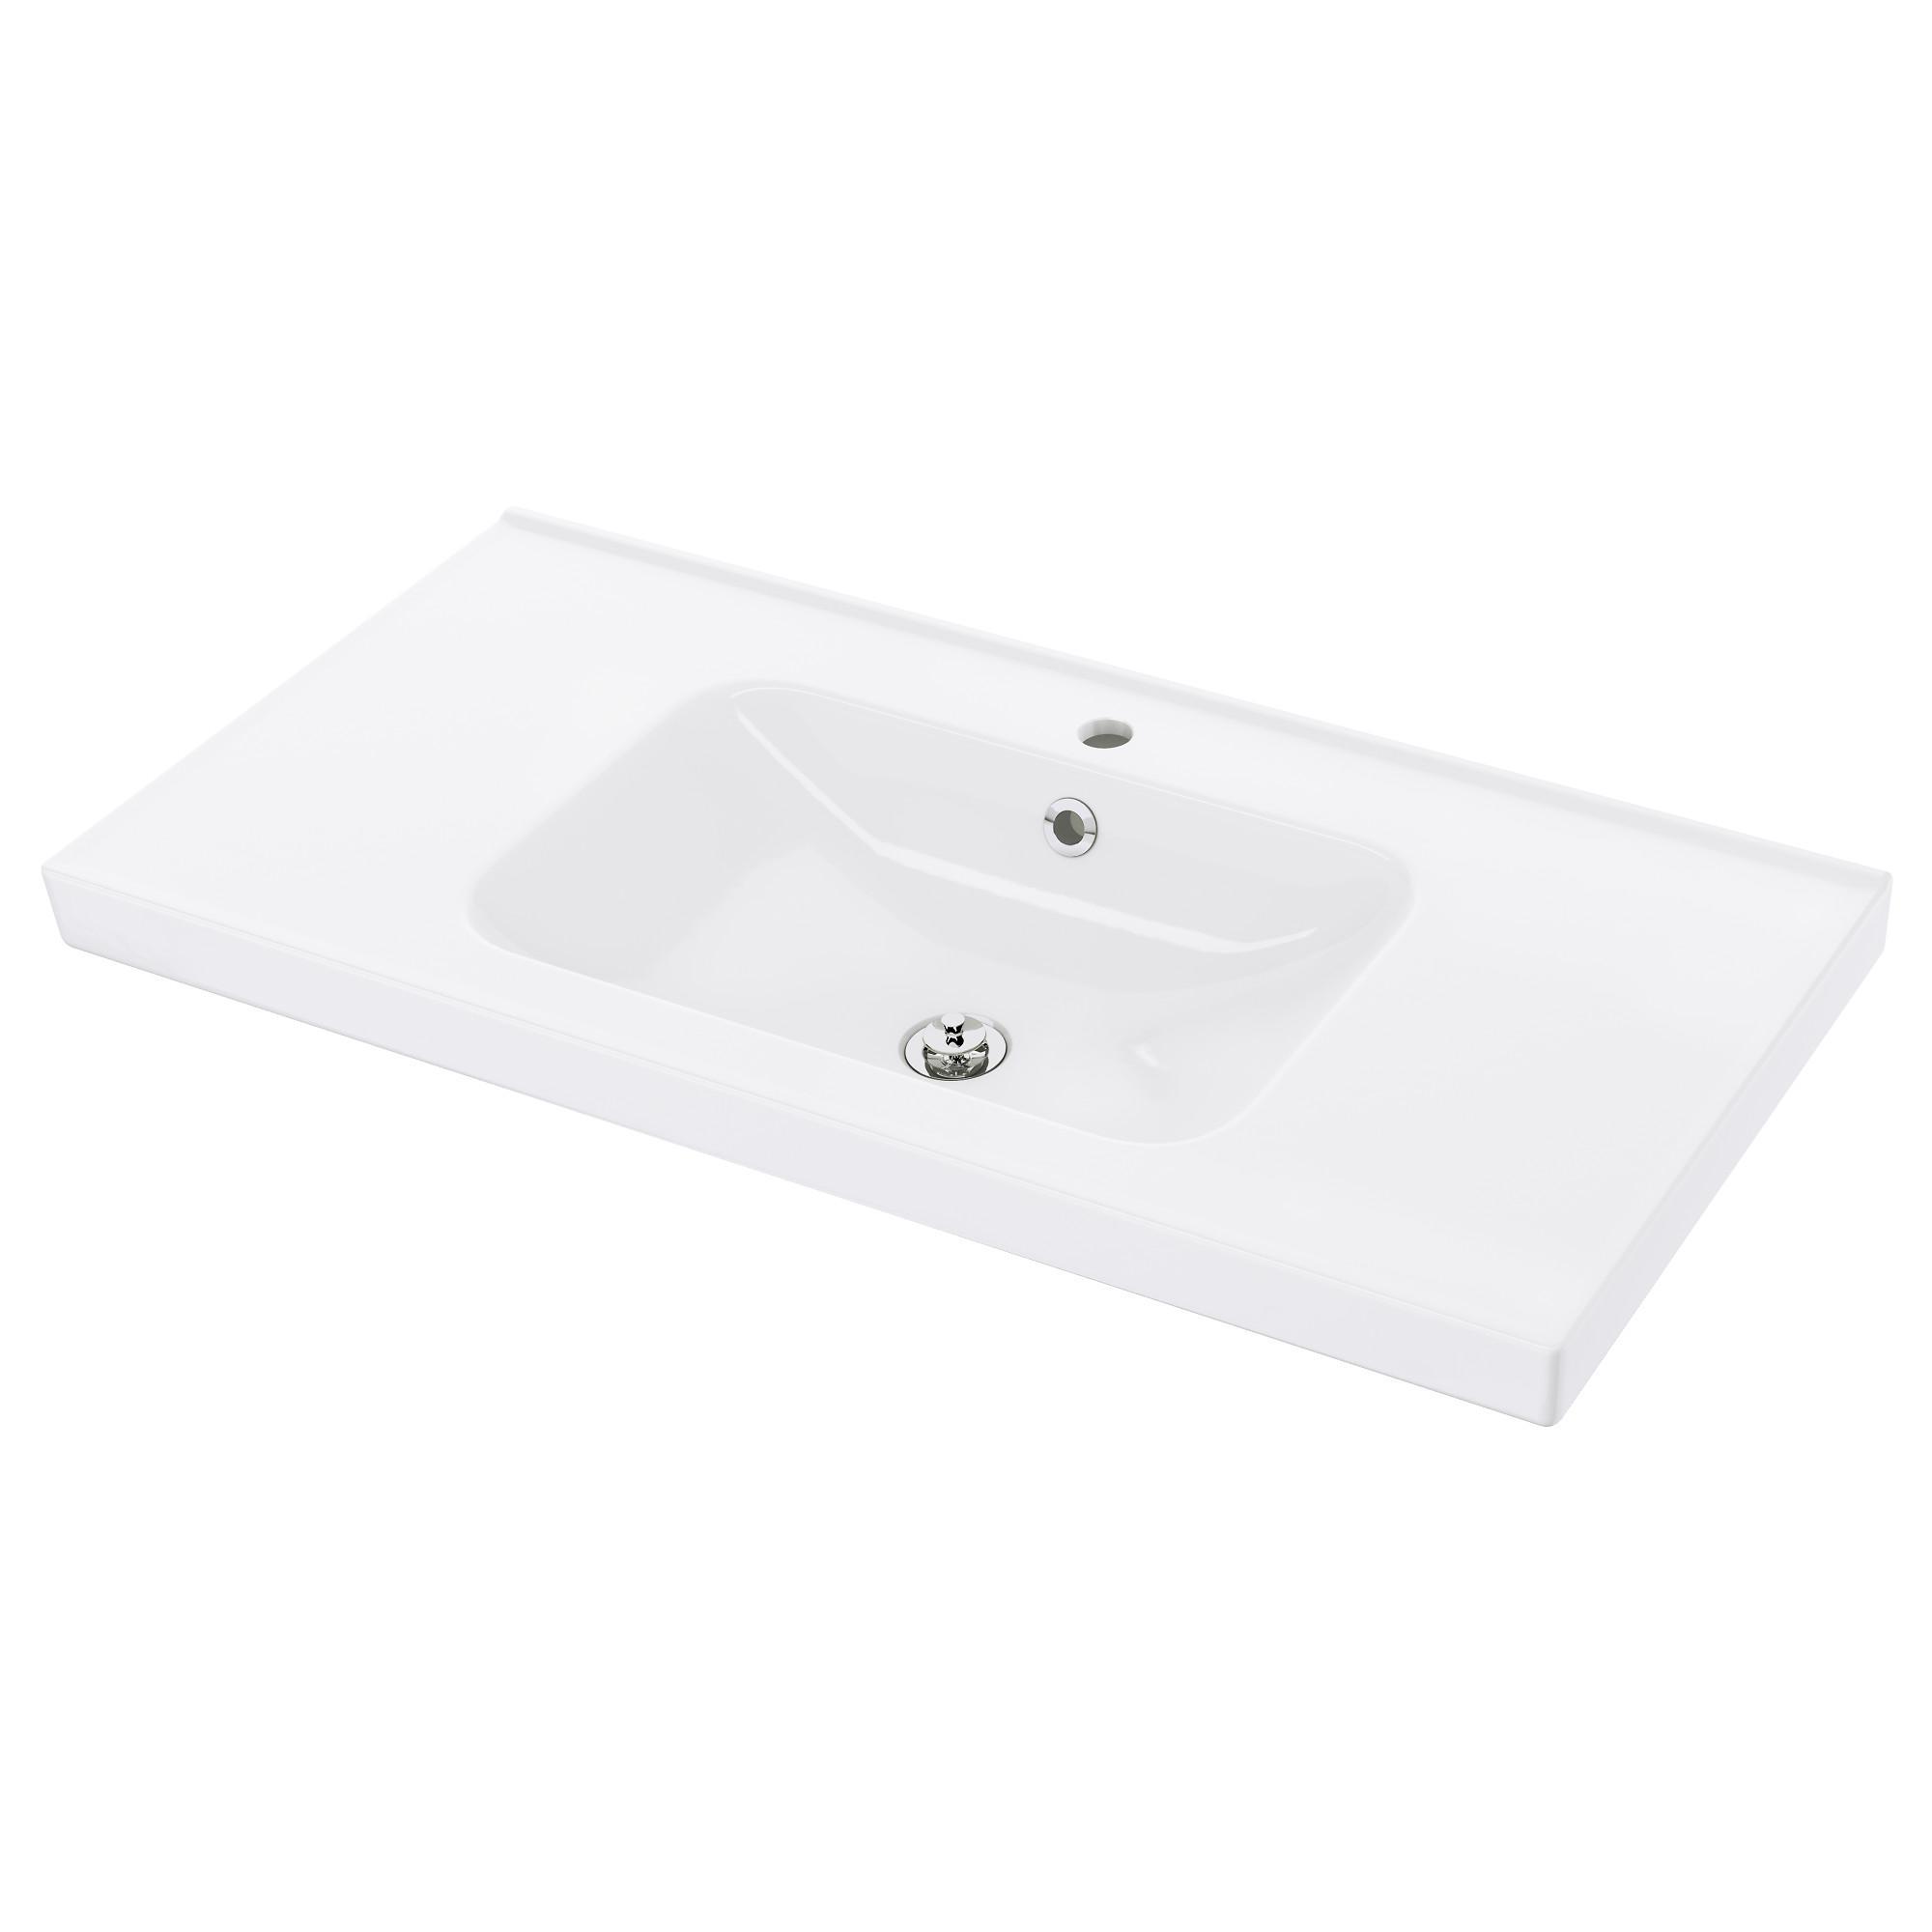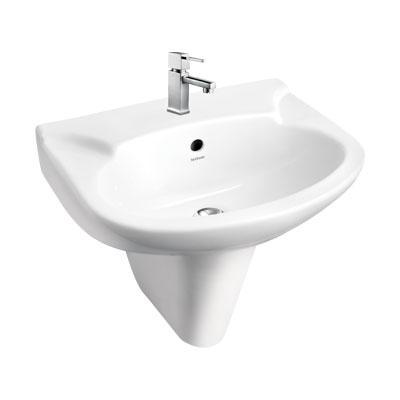The first image is the image on the left, the second image is the image on the right. Evaluate the accuracy of this statement regarding the images: "One image shows a rectangular, nonpedestal sink with an integrated flat counter.". Is it true? Answer yes or no. Yes. 